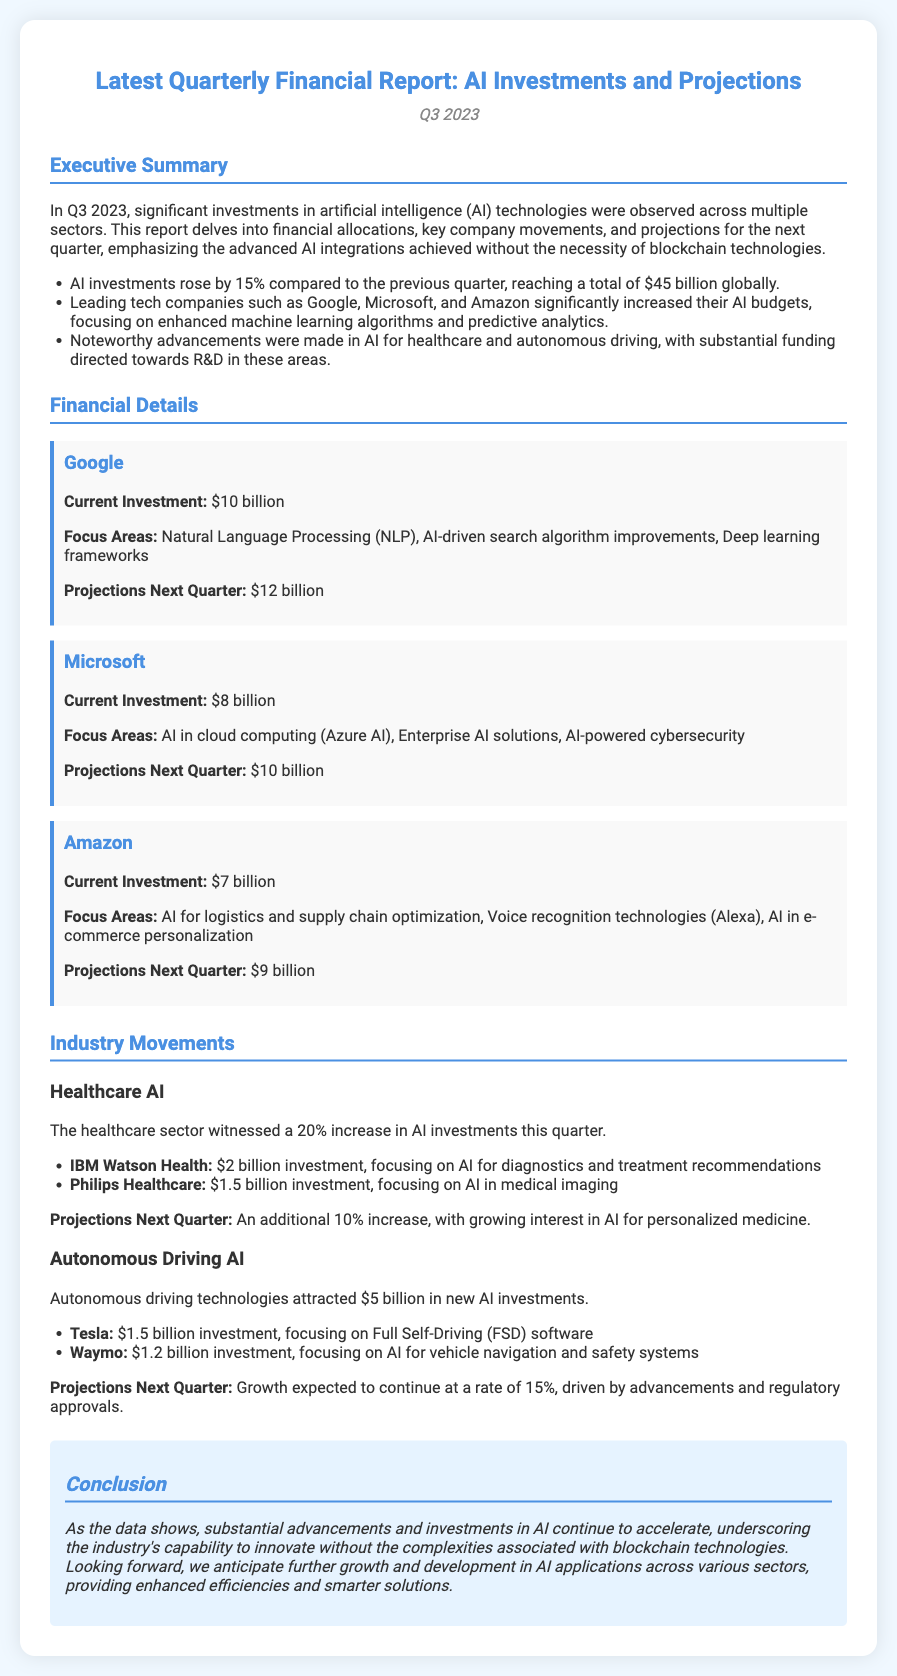what was the total AI investment in Q3 2023? The document states that AI investments rose by 15% reaching a total of $45 billion.
Answer: $45 billion which company had the highest investment in AI? According to the report, Google had the highest investment of $10 billion.
Answer: Google what was Microsoft's current investment amount? The current investment for Microsoft is explicitly mentioned in the report.
Answer: $8 billion what is the projected investment for Amazon next quarter? The document provides a specific projection for Amazon's investment in the next quarter.
Answer: $9 billion how much did IBM Watson Health invest in AI for diagnostics? The report specifies the investment amount made by IBM Watson Health for AI diagnostics.
Answer: $2 billion which sector saw a 20% increase in AI investments this quarter? The document notes a growth in AI investments specifically in the healthcare sector.
Answer: Healthcare what is the projected growth rate for autonomous driving technologies next quarter? The report mentions the expected growth rate for autonomous driving technologies for the next quarter.
Answer: 15% which technology area is highlighted for Google's increased focus? Google is focusing on Natural Language Processing, as outlined in the report.
Answer: Natural Language Processing what is the style of the summary section in the document? The executive summary section provides a concise overview of financial allocations and company movements in AI investments.
Answer: Executive summary 